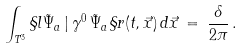Convert formula to latex. <formula><loc_0><loc_0><loc_500><loc_500>\int _ { T ^ { 3 } } \S l \tilde { \Psi } _ { a } \, | \, \gamma ^ { 0 } \, \tilde { \Psi } _ { a } \S r ( t , \vec { x } ) \, d \vec { x } \, = \, \frac { \delta } { 2 \pi } \, .</formula> 